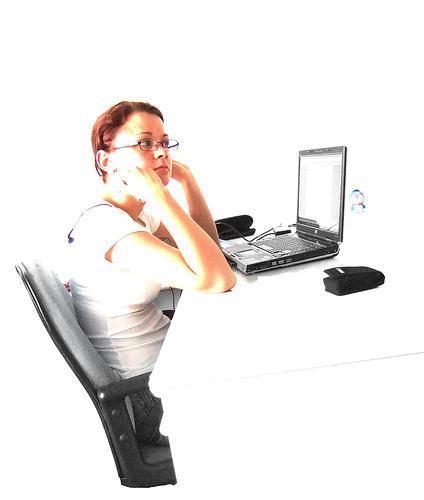How many people are shown?
Give a very brief answer. 1. 